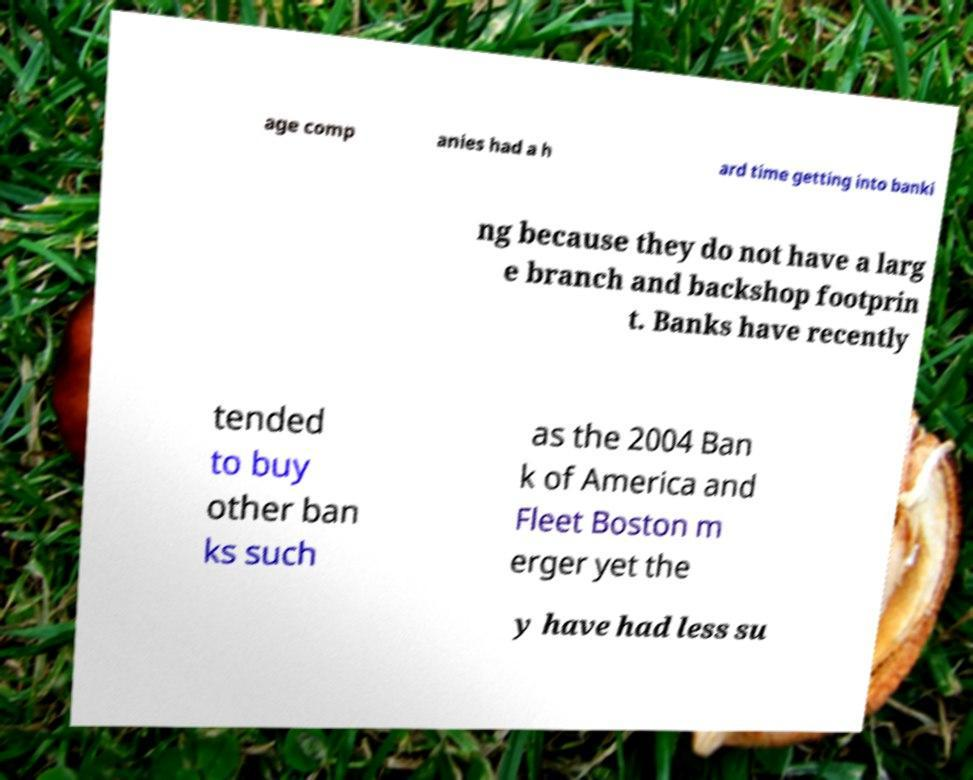Could you assist in decoding the text presented in this image and type it out clearly? age comp anies had a h ard time getting into banki ng because they do not have a larg e branch and backshop footprin t. Banks have recently tended to buy other ban ks such as the 2004 Ban k of America and Fleet Boston m erger yet the y have had less su 